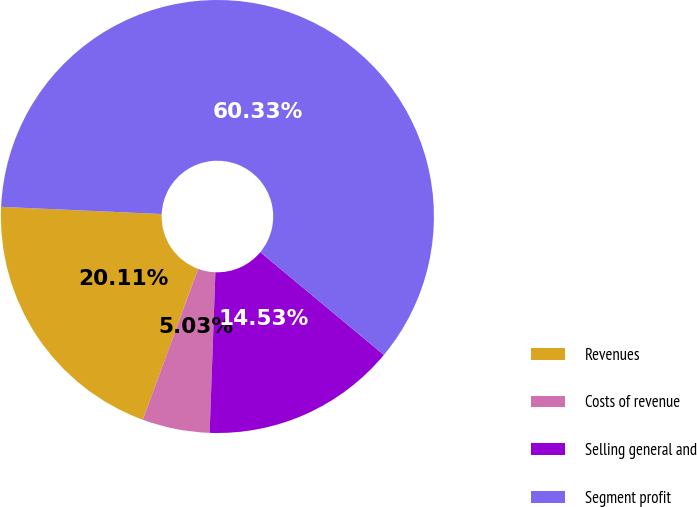Convert chart to OTSL. <chart><loc_0><loc_0><loc_500><loc_500><pie_chart><fcel>Revenues<fcel>Costs of revenue<fcel>Selling general and<fcel>Segment profit<nl><fcel>20.11%<fcel>5.03%<fcel>14.53%<fcel>60.34%<nl></chart> 